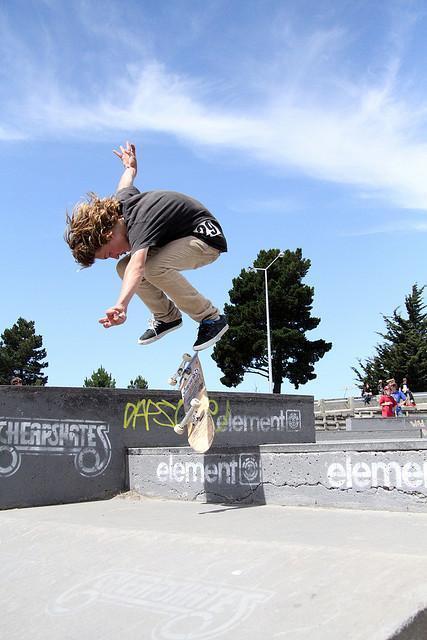How many people are in the photo?
Give a very brief answer. 1. 